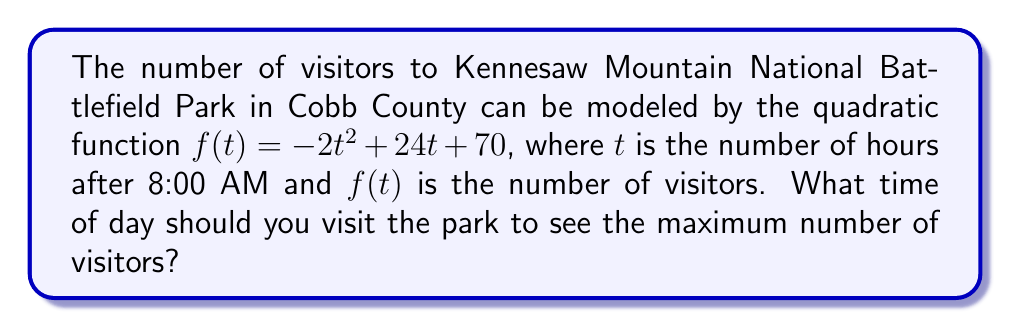Solve this math problem. 1) To find the maximum number of visitors, we need to determine the vertex of the parabola. For a quadratic function in the form $f(t) = at^2 + bt + c$, the t-coordinate of the vertex is given by $t = -\frac{b}{2a}$.

2) In our function $f(t) = -2t^2 + 24t + 70$, we have:
   $a = -2$
   $b = 24$
   $c = 70$

3) Plugging into the formula:
   $t = -\frac{b}{2a} = -\frac{24}{2(-2)} = -\frac{24}{-4} = 6$

4) This means the maximum occurs 6 hours after 8:00 AM.

5) To convert to time of day:
   8:00 AM + 6 hours = 2:00 PM

Therefore, you should visit at 2:00 PM to see the maximum number of visitors.
Answer: 2:00 PM 